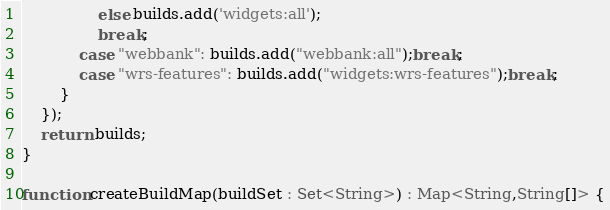Convert code to text. <code><loc_0><loc_0><loc_500><loc_500><_TypeScript_>                else builds.add('widgets:all');
                break;
            case "webbank": builds.add("webbank:all");break;                
            case "wrs-features": builds.add("widgets:wrs-features");break; 
        }
    });
    return builds;
}

function createBuildMap(buildSet : Set<String>) : Map<String,String[]> {</code> 